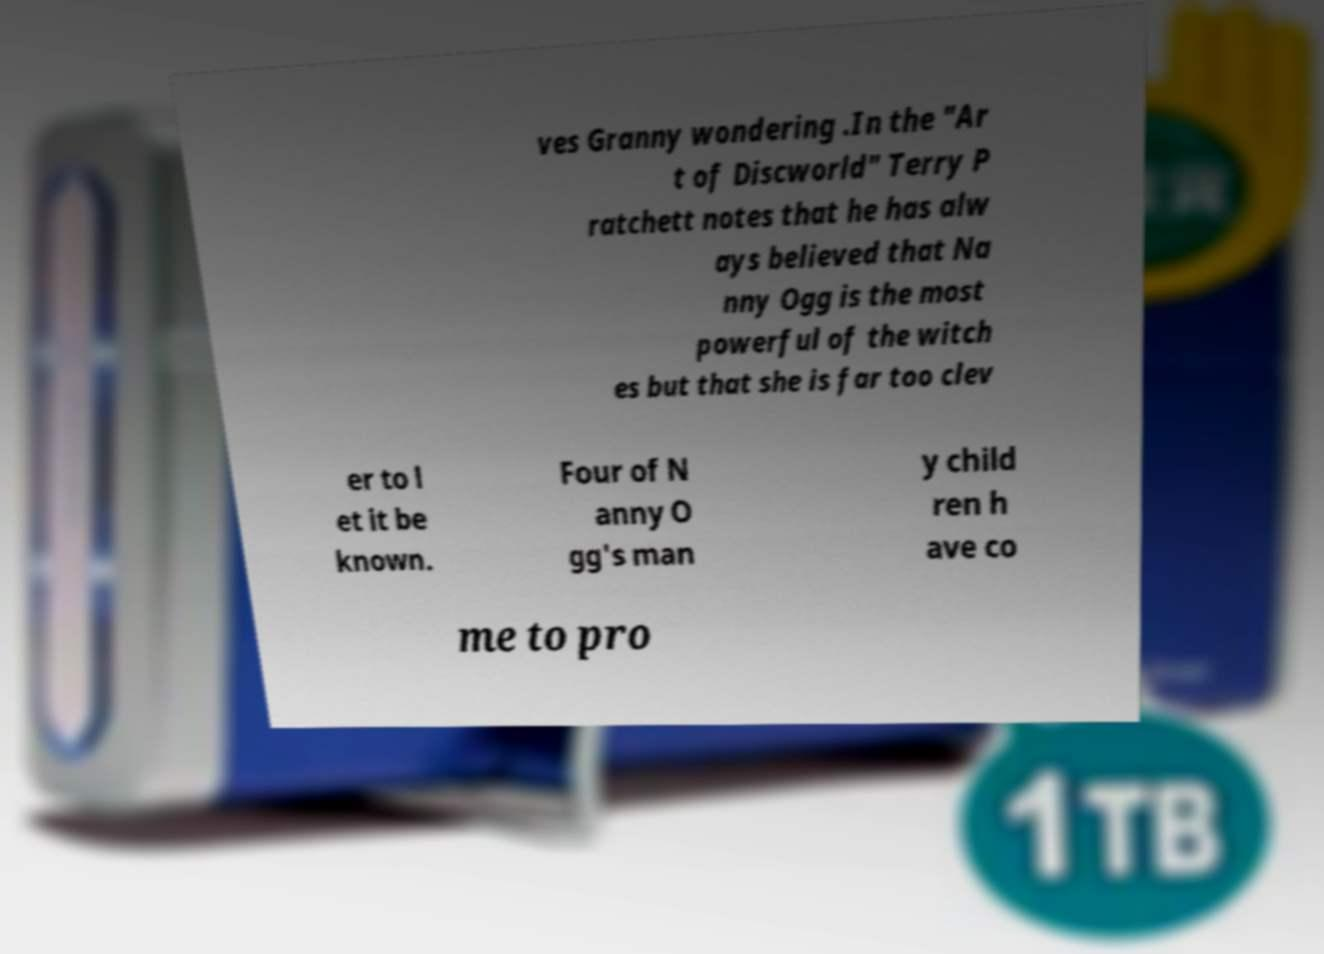There's text embedded in this image that I need extracted. Can you transcribe it verbatim? ves Granny wondering .In the "Ar t of Discworld" Terry P ratchett notes that he has alw ays believed that Na nny Ogg is the most powerful of the witch es but that she is far too clev er to l et it be known. Four of N anny O gg's man y child ren h ave co me to pro 